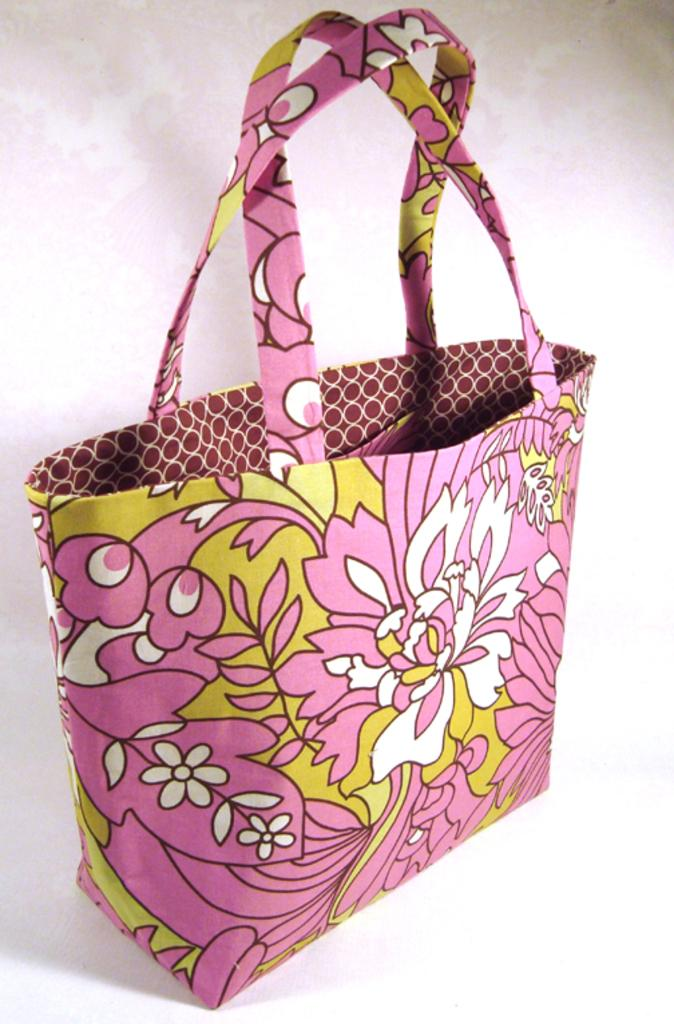What is the main subject of the image? The main subject of the image is a pink handbag. What is the color of the floor in the image? The floor in the image is white. How many colors can be seen on the handbag? The handbag has three colors: white, pink, and green. What type of design is featured on the handbag? The handbag has a floral design. What story does the handbag's dad tell about the slave in the image? There is no mention of a dad, story, or slave in the image; it features a pink handbag with a floral design on a white floor. 